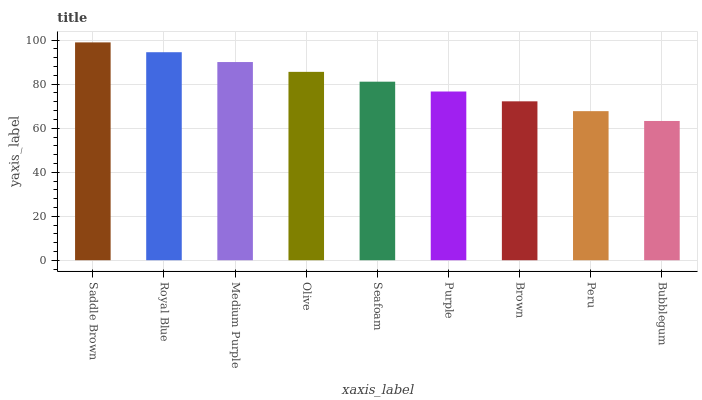Is Bubblegum the minimum?
Answer yes or no. Yes. Is Saddle Brown the maximum?
Answer yes or no. Yes. Is Royal Blue the minimum?
Answer yes or no. No. Is Royal Blue the maximum?
Answer yes or no. No. Is Saddle Brown greater than Royal Blue?
Answer yes or no. Yes. Is Royal Blue less than Saddle Brown?
Answer yes or no. Yes. Is Royal Blue greater than Saddle Brown?
Answer yes or no. No. Is Saddle Brown less than Royal Blue?
Answer yes or no. No. Is Seafoam the high median?
Answer yes or no. Yes. Is Seafoam the low median?
Answer yes or no. Yes. Is Olive the high median?
Answer yes or no. No. Is Medium Purple the low median?
Answer yes or no. No. 